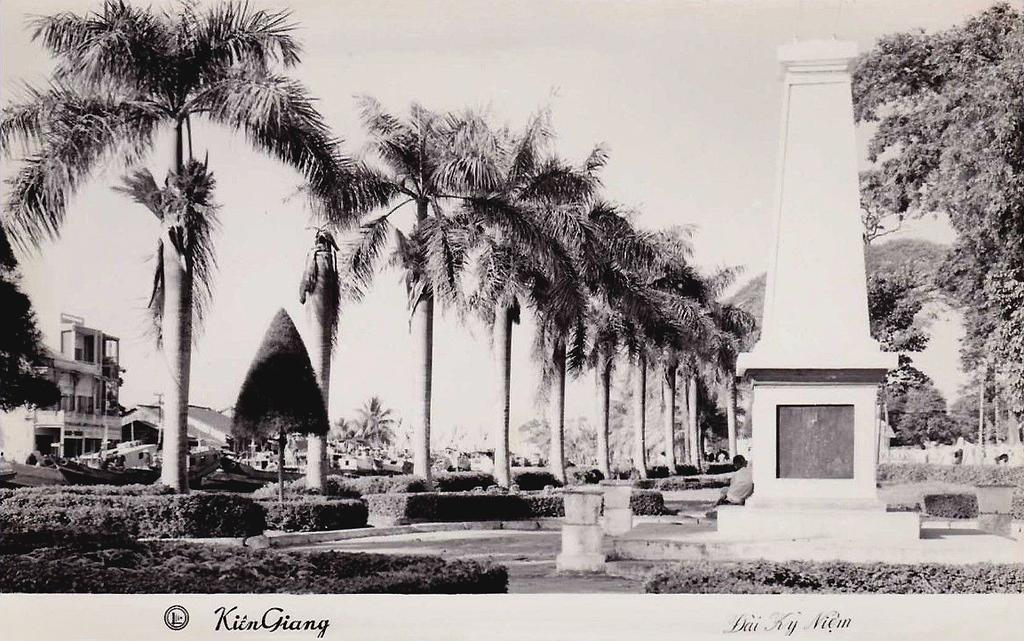What can be seen on the right side of the image? There is a memorial on the right side of the image. What is located on the left side of the image? There are trees and buildings on the left side of the image. What is visible at the top of the image? The sky is visible at the top of the image. What is the color scheme of the image? The image is in black and white. Can you tell me how many basketballs are visible in the image? There are no basketballs present in the image. What type of lead is used in the memorial on the right side of the image? There is no mention of lead in the image, and the memorial does not appear to be made of lead. 